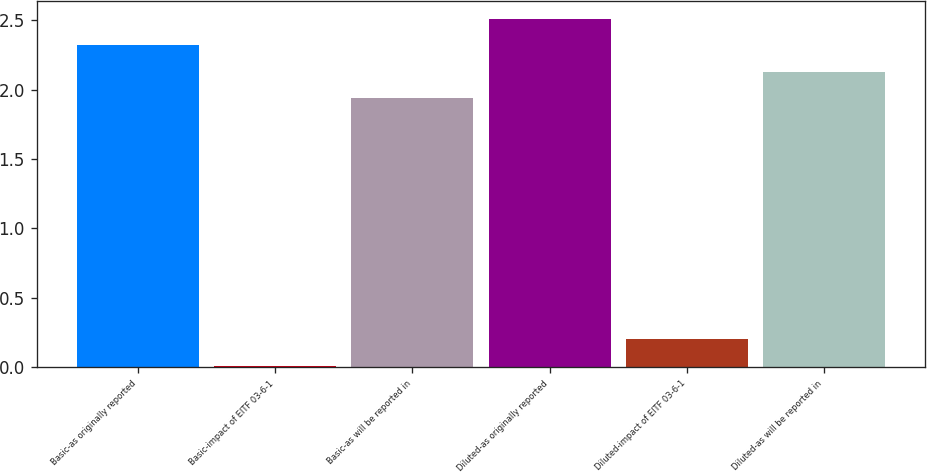<chart> <loc_0><loc_0><loc_500><loc_500><bar_chart><fcel>Basic-as originally reported<fcel>Basic-impact of EITF 03-6-1<fcel>Basic-as will be reported in<fcel>Diluted-as originally reported<fcel>Diluted-impact of EITF 03-6-1<fcel>Diluted-as will be reported in<nl><fcel>2.32<fcel>0.01<fcel>1.94<fcel>2.51<fcel>0.2<fcel>2.13<nl></chart> 